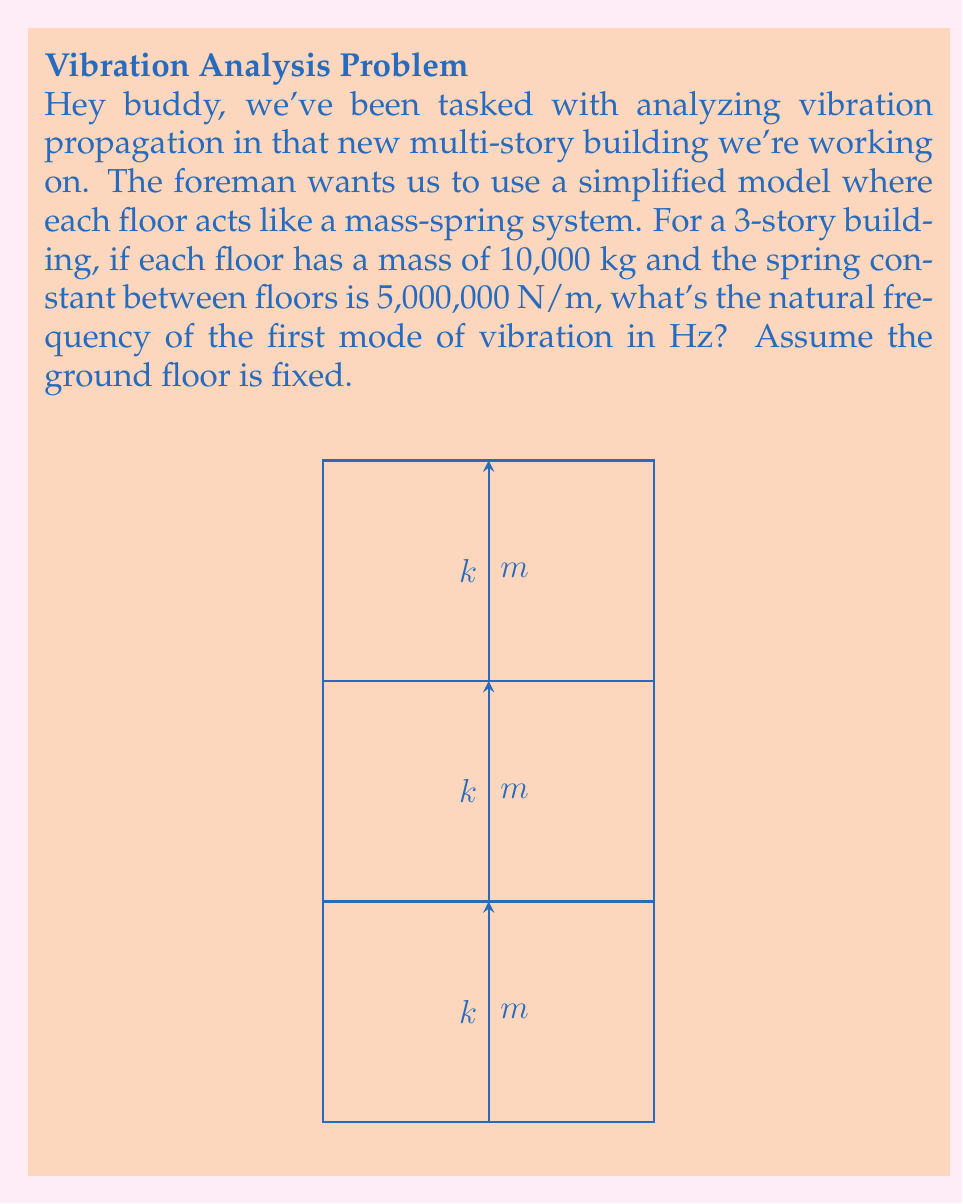Help me with this question. Alright, let's break this down step-by-step:

1) For a multi-story building modeled as a mass-spring system, we can use the equation of motion for coupled oscillators. The natural frequencies are found by solving the eigenvalue problem:

   $$(K - \omega^2 M)X = 0$$

   where $K$ is the stiffness matrix, $M$ is the mass matrix, $\omega$ is the angular frequency, and $X$ is the mode shape.

2) For a 3-story building with identical masses and spring constants, the matrices are:

   $$K = k\begin{bmatrix}
   2 & -1 & 0 \\
   -1 & 2 & -1 \\
   0 & -1 & 1
   \end{bmatrix}$$

   $$M = m\begin{bmatrix}
   1 & 0 & 0 \\
   0 & 1 & 0 \\
   0 & 0 & 1
   \end{bmatrix}$$

3) The characteristic equation is:

   $$det(K - \omega^2 M) = 0$$

4) Solving this equation gives us three eigenvalues, corresponding to the three natural frequencies. The smallest eigenvalue corresponds to the first mode of vibration.

5) For this specific case, the eigenvalues are approximately:

   $$\omega_1^2 = 0.1981k/m$$
   $$\omega_2^2 = 1.5550k/m$$
   $$\omega_3^2 = 2.2469k/m$$

6) We're interested in $\omega_1$. Substituting the given values:

   $$\omega_1 = \sqrt{0.1981 \times 5,000,000 / 10,000} = 9.9524 \text{ rad/s}$$

7) To convert from angular frequency to frequency in Hz, we divide by $2\pi$:

   $$f_1 = \omega_1 / (2\pi) = 9.9524 / (2\pi) = 1.5838 \text{ Hz}$$
Answer: 1.58 Hz 